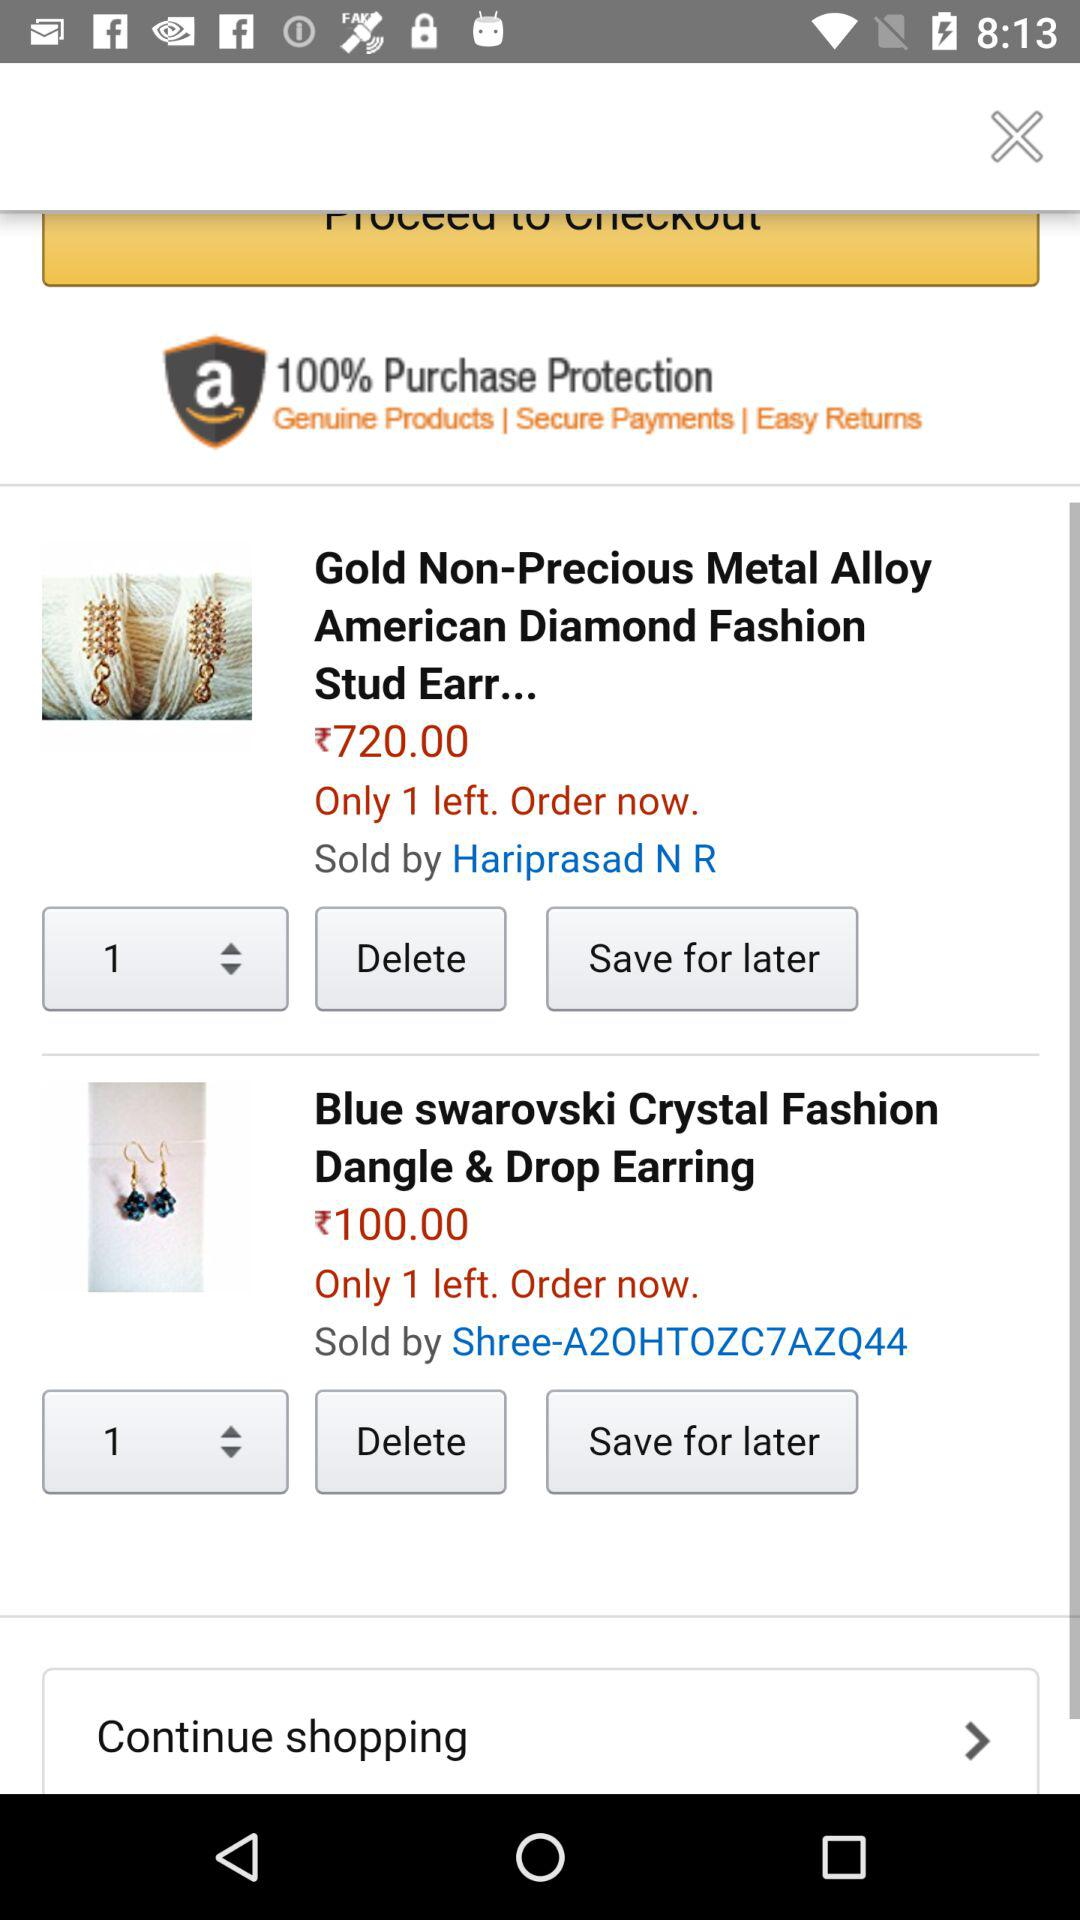What is the price of "Gold Non-Precious Metal Alloy American Diamond Fashion Stud Earring"? The price is ₹720.00. 